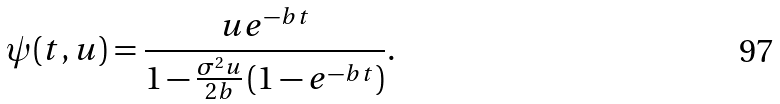<formula> <loc_0><loc_0><loc_500><loc_500>\psi ( t , u ) = \frac { u e ^ { - b t } } { 1 - \frac { \sigma ^ { 2 } u } { 2 b } \left ( 1 - e ^ { - b t } \right ) } .</formula> 